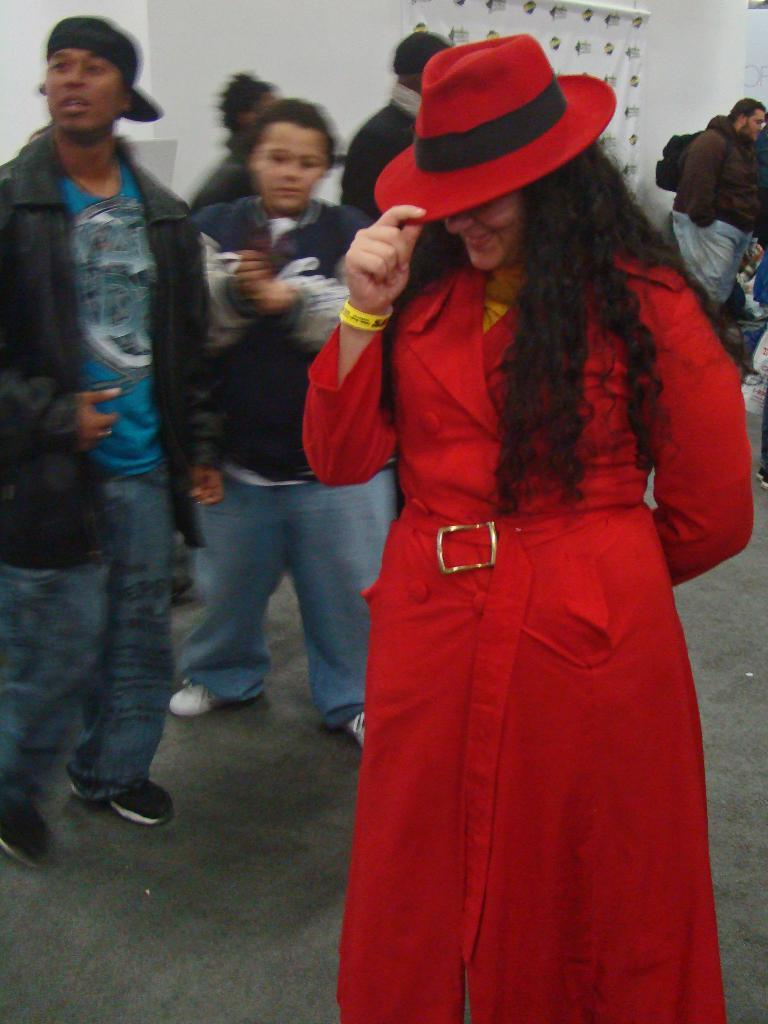How many people are in the image? There are people in the image, but the exact number is not specified. What is the people's position in the image? The people are standing on the floor. What type of home does the writer live in, as depicted in the image? There is no information about a home or a writer in the image, so this question cannot be answered. 